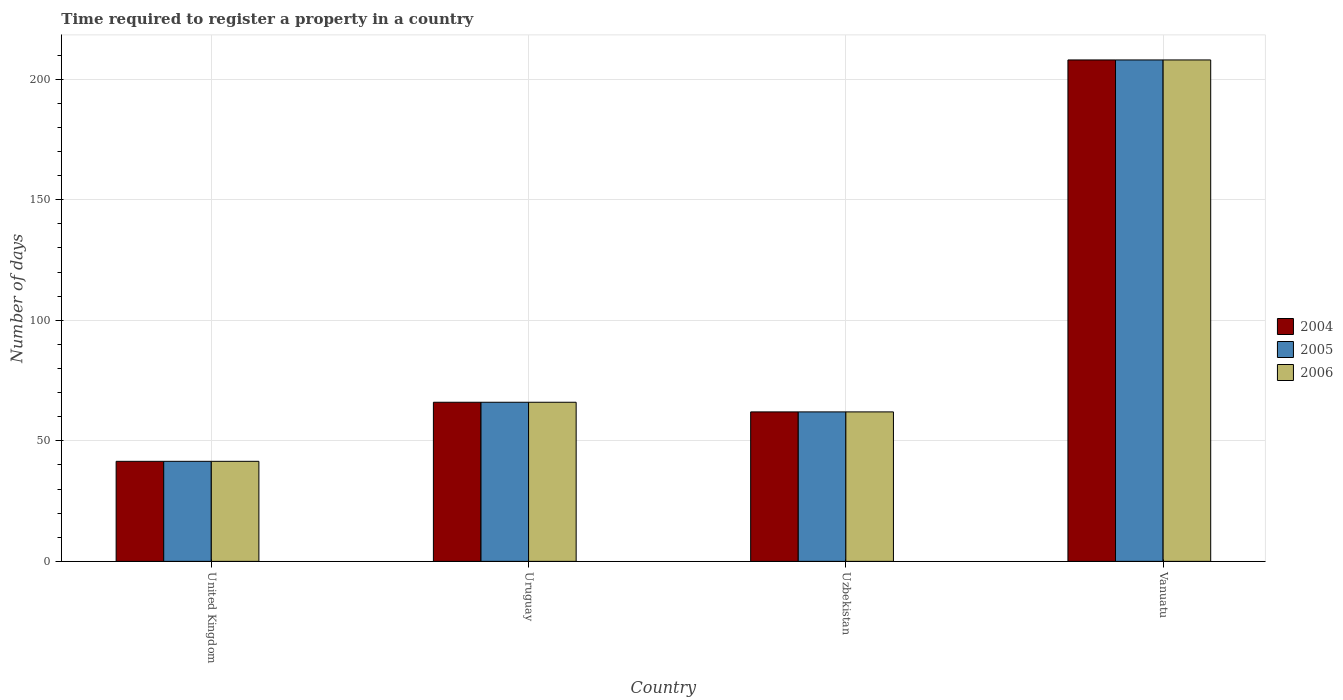How many different coloured bars are there?
Keep it short and to the point. 3. How many groups of bars are there?
Provide a succinct answer. 4. Are the number of bars per tick equal to the number of legend labels?
Your response must be concise. Yes. Are the number of bars on each tick of the X-axis equal?
Offer a terse response. Yes. How many bars are there on the 4th tick from the left?
Provide a succinct answer. 3. How many bars are there on the 1st tick from the right?
Your answer should be very brief. 3. What is the label of the 2nd group of bars from the left?
Offer a very short reply. Uruguay. What is the number of days required to register a property in 2005 in Uruguay?
Provide a succinct answer. 66. Across all countries, what is the maximum number of days required to register a property in 2005?
Make the answer very short. 208. Across all countries, what is the minimum number of days required to register a property in 2005?
Offer a very short reply. 41.5. In which country was the number of days required to register a property in 2005 maximum?
Provide a short and direct response. Vanuatu. What is the total number of days required to register a property in 2005 in the graph?
Keep it short and to the point. 377.5. What is the difference between the number of days required to register a property in 2005 in United Kingdom and that in Vanuatu?
Keep it short and to the point. -166.5. What is the difference between the number of days required to register a property in 2006 in Vanuatu and the number of days required to register a property in 2004 in Uruguay?
Provide a succinct answer. 142. What is the average number of days required to register a property in 2005 per country?
Your answer should be very brief. 94.38. What is the difference between the number of days required to register a property of/in 2006 and number of days required to register a property of/in 2005 in Uzbekistan?
Give a very brief answer. 0. What is the ratio of the number of days required to register a property in 2005 in Uruguay to that in Vanuatu?
Provide a short and direct response. 0.32. What is the difference between the highest and the second highest number of days required to register a property in 2005?
Provide a short and direct response. 142. What is the difference between the highest and the lowest number of days required to register a property in 2006?
Offer a terse response. 166.5. In how many countries, is the number of days required to register a property in 2006 greater than the average number of days required to register a property in 2006 taken over all countries?
Offer a very short reply. 1. Is the sum of the number of days required to register a property in 2006 in United Kingdom and Vanuatu greater than the maximum number of days required to register a property in 2004 across all countries?
Keep it short and to the point. Yes. What does the 2nd bar from the left in Uzbekistan represents?
Ensure brevity in your answer.  2005. Is it the case that in every country, the sum of the number of days required to register a property in 2005 and number of days required to register a property in 2004 is greater than the number of days required to register a property in 2006?
Provide a succinct answer. Yes. What is the difference between two consecutive major ticks on the Y-axis?
Your answer should be compact. 50. Does the graph contain grids?
Make the answer very short. Yes. How many legend labels are there?
Offer a very short reply. 3. What is the title of the graph?
Keep it short and to the point. Time required to register a property in a country. Does "1960" appear as one of the legend labels in the graph?
Your answer should be compact. No. What is the label or title of the Y-axis?
Ensure brevity in your answer.  Number of days. What is the Number of days in 2004 in United Kingdom?
Give a very brief answer. 41.5. What is the Number of days in 2005 in United Kingdom?
Your answer should be compact. 41.5. What is the Number of days of 2006 in United Kingdom?
Give a very brief answer. 41.5. What is the Number of days in 2004 in Uruguay?
Make the answer very short. 66. What is the Number of days in 2005 in Uruguay?
Provide a short and direct response. 66. What is the Number of days of 2004 in Uzbekistan?
Your answer should be very brief. 62. What is the Number of days in 2005 in Uzbekistan?
Offer a very short reply. 62. What is the Number of days of 2004 in Vanuatu?
Your response must be concise. 208. What is the Number of days in 2005 in Vanuatu?
Give a very brief answer. 208. What is the Number of days in 2006 in Vanuatu?
Your response must be concise. 208. Across all countries, what is the maximum Number of days in 2004?
Ensure brevity in your answer.  208. Across all countries, what is the maximum Number of days of 2005?
Offer a terse response. 208. Across all countries, what is the maximum Number of days of 2006?
Keep it short and to the point. 208. Across all countries, what is the minimum Number of days in 2004?
Offer a very short reply. 41.5. Across all countries, what is the minimum Number of days in 2005?
Your answer should be compact. 41.5. Across all countries, what is the minimum Number of days of 2006?
Provide a short and direct response. 41.5. What is the total Number of days of 2004 in the graph?
Provide a short and direct response. 377.5. What is the total Number of days in 2005 in the graph?
Provide a succinct answer. 377.5. What is the total Number of days in 2006 in the graph?
Offer a terse response. 377.5. What is the difference between the Number of days of 2004 in United Kingdom and that in Uruguay?
Offer a very short reply. -24.5. What is the difference between the Number of days of 2005 in United Kingdom and that in Uruguay?
Provide a succinct answer. -24.5. What is the difference between the Number of days of 2006 in United Kingdom and that in Uruguay?
Provide a succinct answer. -24.5. What is the difference between the Number of days in 2004 in United Kingdom and that in Uzbekistan?
Your answer should be very brief. -20.5. What is the difference between the Number of days in 2005 in United Kingdom and that in Uzbekistan?
Provide a succinct answer. -20.5. What is the difference between the Number of days of 2006 in United Kingdom and that in Uzbekistan?
Your response must be concise. -20.5. What is the difference between the Number of days of 2004 in United Kingdom and that in Vanuatu?
Make the answer very short. -166.5. What is the difference between the Number of days of 2005 in United Kingdom and that in Vanuatu?
Offer a terse response. -166.5. What is the difference between the Number of days in 2006 in United Kingdom and that in Vanuatu?
Offer a terse response. -166.5. What is the difference between the Number of days in 2005 in Uruguay and that in Uzbekistan?
Provide a short and direct response. 4. What is the difference between the Number of days in 2006 in Uruguay and that in Uzbekistan?
Provide a short and direct response. 4. What is the difference between the Number of days of 2004 in Uruguay and that in Vanuatu?
Give a very brief answer. -142. What is the difference between the Number of days of 2005 in Uruguay and that in Vanuatu?
Provide a short and direct response. -142. What is the difference between the Number of days in 2006 in Uruguay and that in Vanuatu?
Provide a succinct answer. -142. What is the difference between the Number of days in 2004 in Uzbekistan and that in Vanuatu?
Your answer should be compact. -146. What is the difference between the Number of days of 2005 in Uzbekistan and that in Vanuatu?
Offer a very short reply. -146. What is the difference between the Number of days of 2006 in Uzbekistan and that in Vanuatu?
Your response must be concise. -146. What is the difference between the Number of days in 2004 in United Kingdom and the Number of days in 2005 in Uruguay?
Make the answer very short. -24.5. What is the difference between the Number of days in 2004 in United Kingdom and the Number of days in 2006 in Uruguay?
Make the answer very short. -24.5. What is the difference between the Number of days in 2005 in United Kingdom and the Number of days in 2006 in Uruguay?
Your answer should be compact. -24.5. What is the difference between the Number of days in 2004 in United Kingdom and the Number of days in 2005 in Uzbekistan?
Provide a short and direct response. -20.5. What is the difference between the Number of days in 2004 in United Kingdom and the Number of days in 2006 in Uzbekistan?
Offer a terse response. -20.5. What is the difference between the Number of days in 2005 in United Kingdom and the Number of days in 2006 in Uzbekistan?
Ensure brevity in your answer.  -20.5. What is the difference between the Number of days of 2004 in United Kingdom and the Number of days of 2005 in Vanuatu?
Your response must be concise. -166.5. What is the difference between the Number of days of 2004 in United Kingdom and the Number of days of 2006 in Vanuatu?
Offer a very short reply. -166.5. What is the difference between the Number of days in 2005 in United Kingdom and the Number of days in 2006 in Vanuatu?
Make the answer very short. -166.5. What is the difference between the Number of days in 2004 in Uruguay and the Number of days in 2005 in Uzbekistan?
Give a very brief answer. 4. What is the difference between the Number of days in 2004 in Uruguay and the Number of days in 2005 in Vanuatu?
Provide a short and direct response. -142. What is the difference between the Number of days of 2004 in Uruguay and the Number of days of 2006 in Vanuatu?
Offer a very short reply. -142. What is the difference between the Number of days of 2005 in Uruguay and the Number of days of 2006 in Vanuatu?
Your answer should be compact. -142. What is the difference between the Number of days of 2004 in Uzbekistan and the Number of days of 2005 in Vanuatu?
Your answer should be compact. -146. What is the difference between the Number of days in 2004 in Uzbekistan and the Number of days in 2006 in Vanuatu?
Your answer should be very brief. -146. What is the difference between the Number of days in 2005 in Uzbekistan and the Number of days in 2006 in Vanuatu?
Your response must be concise. -146. What is the average Number of days of 2004 per country?
Keep it short and to the point. 94.38. What is the average Number of days of 2005 per country?
Offer a terse response. 94.38. What is the average Number of days of 2006 per country?
Offer a terse response. 94.38. What is the difference between the Number of days in 2004 and Number of days in 2005 in United Kingdom?
Your answer should be compact. 0. What is the difference between the Number of days in 2004 and Number of days in 2005 in Uruguay?
Offer a very short reply. 0. What is the ratio of the Number of days in 2004 in United Kingdom to that in Uruguay?
Provide a short and direct response. 0.63. What is the ratio of the Number of days in 2005 in United Kingdom to that in Uruguay?
Your answer should be compact. 0.63. What is the ratio of the Number of days of 2006 in United Kingdom to that in Uruguay?
Your response must be concise. 0.63. What is the ratio of the Number of days of 2004 in United Kingdom to that in Uzbekistan?
Keep it short and to the point. 0.67. What is the ratio of the Number of days in 2005 in United Kingdom to that in Uzbekistan?
Make the answer very short. 0.67. What is the ratio of the Number of days of 2006 in United Kingdom to that in Uzbekistan?
Offer a very short reply. 0.67. What is the ratio of the Number of days in 2004 in United Kingdom to that in Vanuatu?
Your answer should be compact. 0.2. What is the ratio of the Number of days of 2005 in United Kingdom to that in Vanuatu?
Offer a very short reply. 0.2. What is the ratio of the Number of days in 2006 in United Kingdom to that in Vanuatu?
Offer a terse response. 0.2. What is the ratio of the Number of days of 2004 in Uruguay to that in Uzbekistan?
Your answer should be compact. 1.06. What is the ratio of the Number of days of 2005 in Uruguay to that in Uzbekistan?
Offer a terse response. 1.06. What is the ratio of the Number of days in 2006 in Uruguay to that in Uzbekistan?
Make the answer very short. 1.06. What is the ratio of the Number of days in 2004 in Uruguay to that in Vanuatu?
Your answer should be compact. 0.32. What is the ratio of the Number of days in 2005 in Uruguay to that in Vanuatu?
Your answer should be compact. 0.32. What is the ratio of the Number of days of 2006 in Uruguay to that in Vanuatu?
Your answer should be very brief. 0.32. What is the ratio of the Number of days in 2004 in Uzbekistan to that in Vanuatu?
Give a very brief answer. 0.3. What is the ratio of the Number of days of 2005 in Uzbekistan to that in Vanuatu?
Provide a short and direct response. 0.3. What is the ratio of the Number of days of 2006 in Uzbekistan to that in Vanuatu?
Provide a succinct answer. 0.3. What is the difference between the highest and the second highest Number of days of 2004?
Ensure brevity in your answer.  142. What is the difference between the highest and the second highest Number of days in 2005?
Offer a terse response. 142. What is the difference between the highest and the second highest Number of days of 2006?
Your response must be concise. 142. What is the difference between the highest and the lowest Number of days of 2004?
Give a very brief answer. 166.5. What is the difference between the highest and the lowest Number of days of 2005?
Your answer should be compact. 166.5. What is the difference between the highest and the lowest Number of days of 2006?
Offer a very short reply. 166.5. 